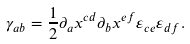Convert formula to latex. <formula><loc_0><loc_0><loc_500><loc_500>\gamma _ { a b } = \frac { 1 } { 2 } \partial _ { a } x ^ { c d } \partial _ { b } x ^ { e f } \varepsilon _ { c e } \varepsilon _ { d f } .</formula> 